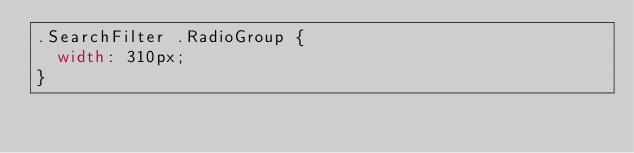<code> <loc_0><loc_0><loc_500><loc_500><_CSS_>.SearchFilter .RadioGroup {
  width: 310px;
}
</code> 